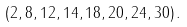<formula> <loc_0><loc_0><loc_500><loc_500>( 2 , 8 , 1 2 , 1 4 , 1 8 , 2 0 , 2 4 , 3 0 ) \, .</formula> 